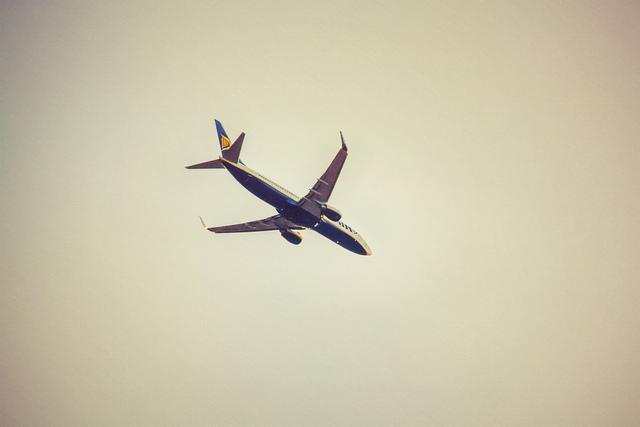How many engines are on the planes?
Give a very brief answer. 2. How many planes?
Give a very brief answer. 1. How many elephants form the line?
Give a very brief answer. 0. 